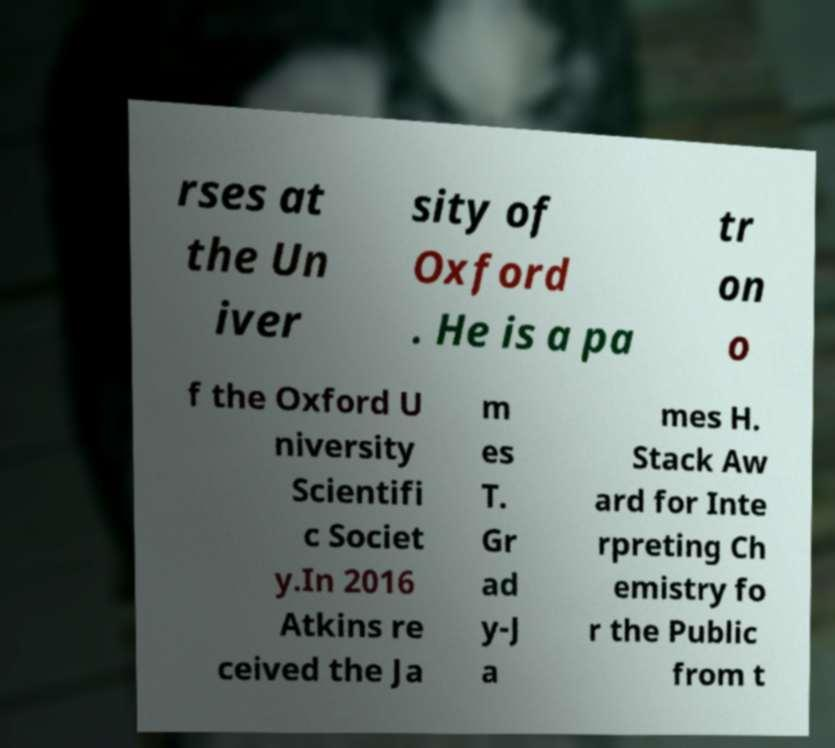Please identify and transcribe the text found in this image. rses at the Un iver sity of Oxford . He is a pa tr on o f the Oxford U niversity Scientifi c Societ y.In 2016 Atkins re ceived the Ja m es T. Gr ad y-J a mes H. Stack Aw ard for Inte rpreting Ch emistry fo r the Public from t 